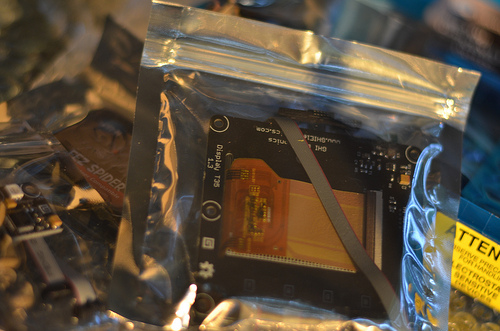<image>
Is the circuit in the bag? Yes. The circuit is contained within or inside the bag, showing a containment relationship. 